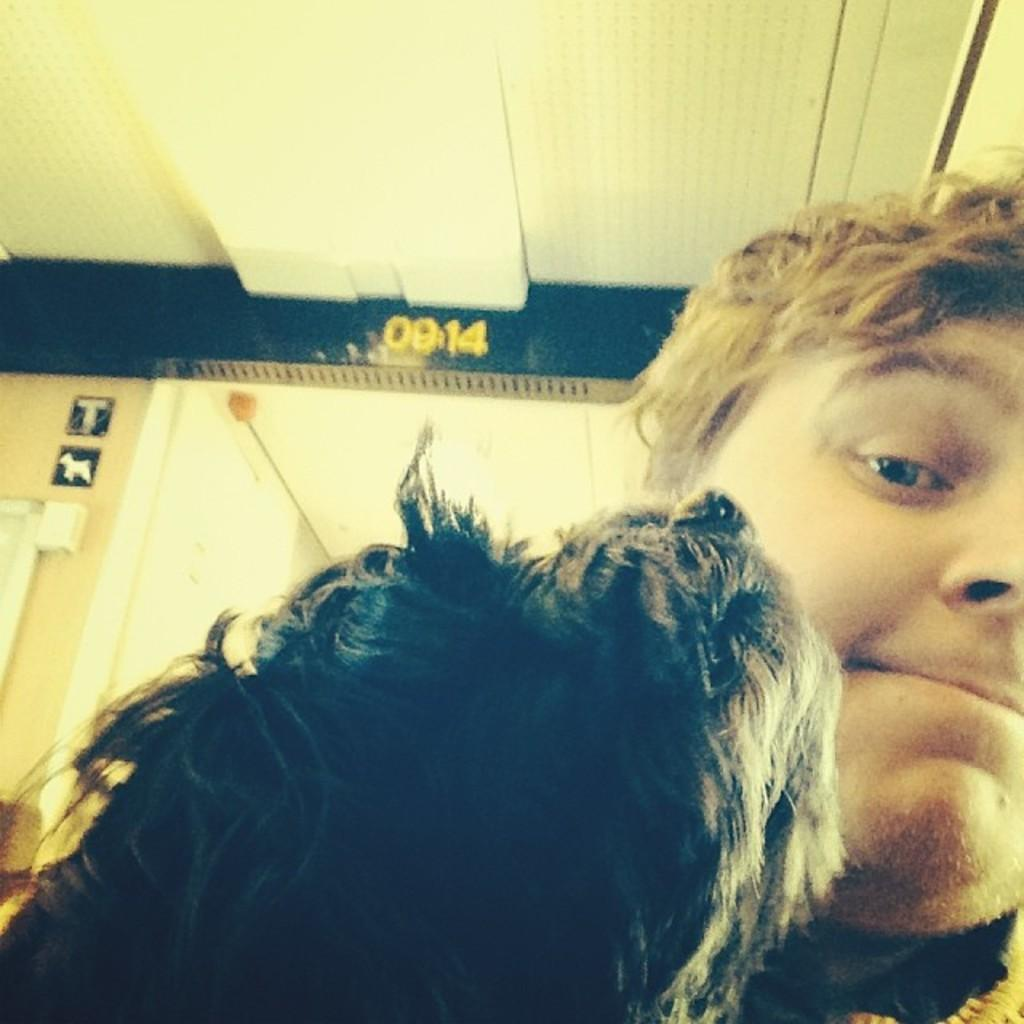What is the person in the image wearing? The person is wearing a black and white dress in the image. What can be seen on the wall in the background of the image? There are boards on the wall in the background of the image. Can you describe the number visible in the top of the image? Yes, there is a number visible in the top of the image. What type of watch is the person wearing in the image? There is no watch visible in the image; the person is wearing a black and white dress. 